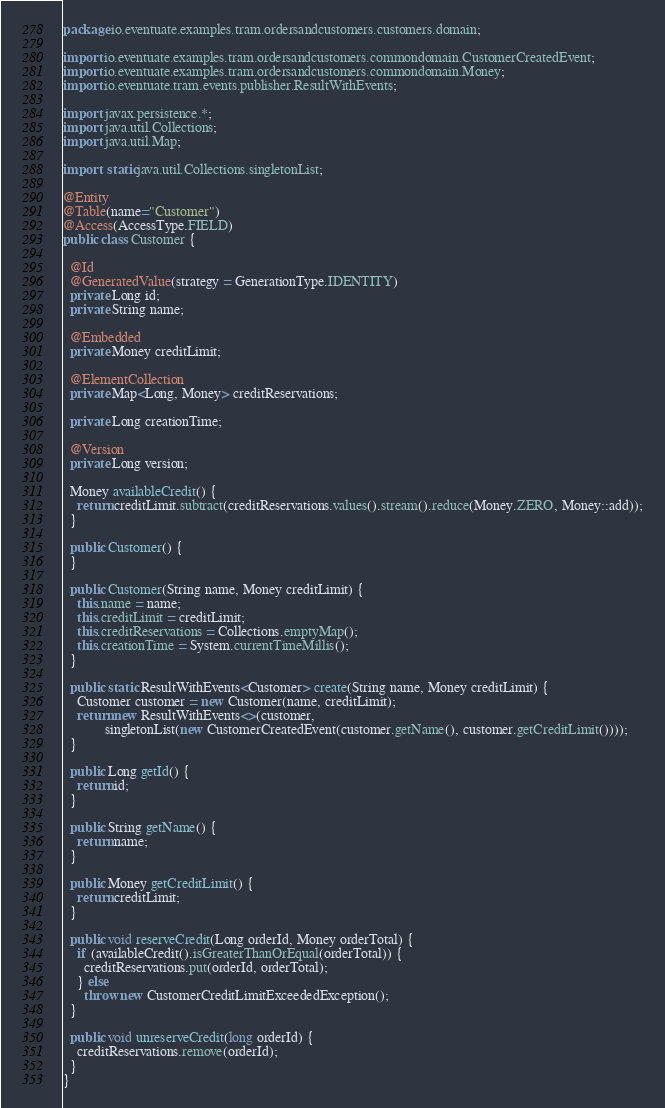<code> <loc_0><loc_0><loc_500><loc_500><_Java_>package io.eventuate.examples.tram.ordersandcustomers.customers.domain;

import io.eventuate.examples.tram.ordersandcustomers.commondomain.CustomerCreatedEvent;
import io.eventuate.examples.tram.ordersandcustomers.commondomain.Money;
import io.eventuate.tram.events.publisher.ResultWithEvents;

import javax.persistence.*;
import java.util.Collections;
import java.util.Map;

import static java.util.Collections.singletonList;

@Entity
@Table(name="Customer")
@Access(AccessType.FIELD)
public class Customer {

  @Id
  @GeneratedValue(strategy = GenerationType.IDENTITY)
  private Long id;
  private String name;

  @Embedded
  private Money creditLimit;

  @ElementCollection
  private Map<Long, Money> creditReservations;

  private Long creationTime;

  @Version
  private Long version;

  Money availableCredit() {
    return creditLimit.subtract(creditReservations.values().stream().reduce(Money.ZERO, Money::add));
  }

  public Customer() {
  }

  public Customer(String name, Money creditLimit) {
    this.name = name;
    this.creditLimit = creditLimit;
    this.creditReservations = Collections.emptyMap();
    this.creationTime = System.currentTimeMillis();
  }

  public static ResultWithEvents<Customer> create(String name, Money creditLimit) {
    Customer customer = new Customer(name, creditLimit);
    return new ResultWithEvents<>(customer,
            singletonList(new CustomerCreatedEvent(customer.getName(), customer.getCreditLimit())));
  }

  public Long getId() {
    return id;
  }

  public String getName() {
    return name;
  }

  public Money getCreditLimit() {
    return creditLimit;
  }

  public void reserveCredit(Long orderId, Money orderTotal) {
    if (availableCredit().isGreaterThanOrEqual(orderTotal)) {
      creditReservations.put(orderId, orderTotal);
    } else
      throw new CustomerCreditLimitExceededException();
  }

  public void unreserveCredit(long orderId) {
    creditReservations.remove(orderId);
  }
}
</code> 